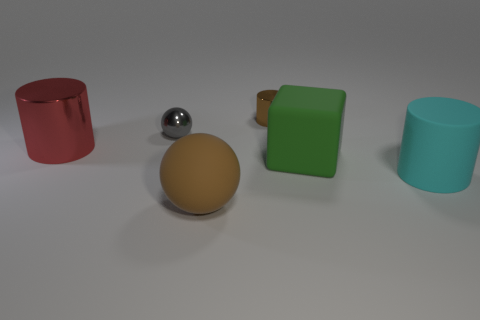There is a ball that is the same color as the tiny cylinder; what size is it?
Ensure brevity in your answer.  Large. What shape is the gray thing?
Provide a succinct answer. Sphere. How many objects are red matte cubes or cyan matte cylinders?
Your answer should be very brief. 1. Do the rubber ball in front of the small brown cylinder and the cylinder that is right of the small shiny cylinder have the same size?
Offer a very short reply. Yes. What number of other objects are the same material as the large block?
Provide a short and direct response. 2. Are there more gray shiny objects to the left of the green block than small brown shiny objects that are in front of the large cyan matte object?
Make the answer very short. Yes. What is the material of the tiny thing that is behind the tiny gray shiny object?
Provide a succinct answer. Metal. Is the green object the same shape as the tiny brown thing?
Offer a very short reply. No. Are there any other things that have the same color as the big matte sphere?
Make the answer very short. Yes. What is the color of the other big metallic thing that is the same shape as the brown shiny object?
Make the answer very short. Red. 